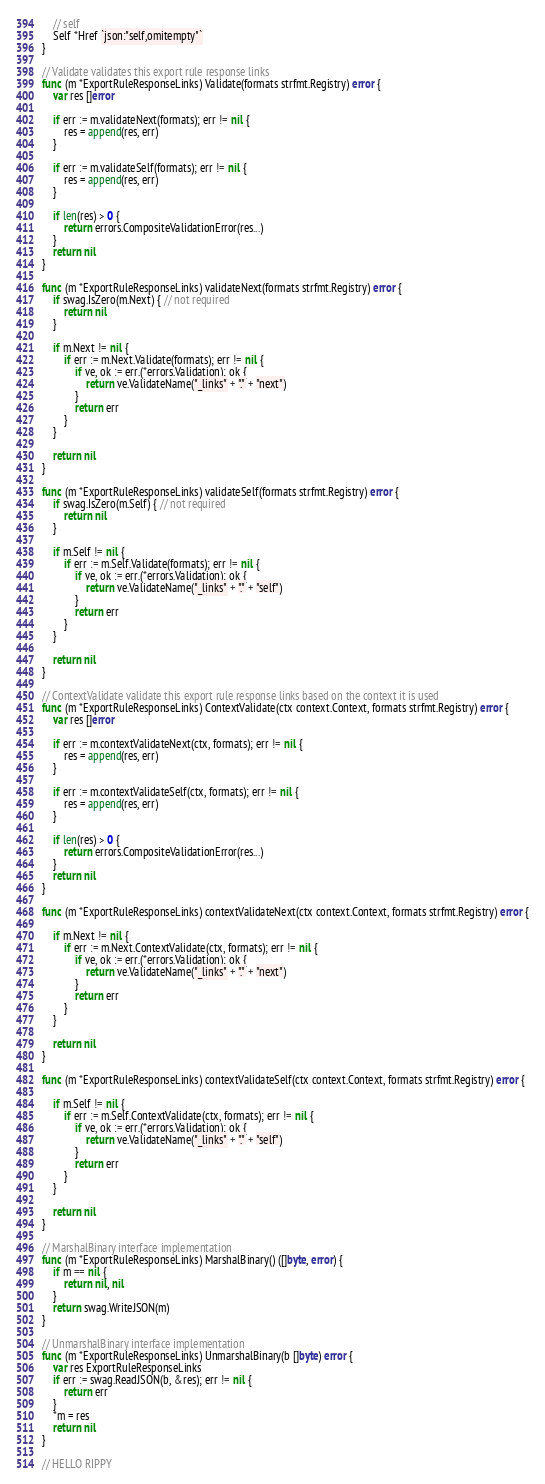<code> <loc_0><loc_0><loc_500><loc_500><_Go_>	// self
	Self *Href `json:"self,omitempty"`
}

// Validate validates this export rule response links
func (m *ExportRuleResponseLinks) Validate(formats strfmt.Registry) error {
	var res []error

	if err := m.validateNext(formats); err != nil {
		res = append(res, err)
	}

	if err := m.validateSelf(formats); err != nil {
		res = append(res, err)
	}

	if len(res) > 0 {
		return errors.CompositeValidationError(res...)
	}
	return nil
}

func (m *ExportRuleResponseLinks) validateNext(formats strfmt.Registry) error {
	if swag.IsZero(m.Next) { // not required
		return nil
	}

	if m.Next != nil {
		if err := m.Next.Validate(formats); err != nil {
			if ve, ok := err.(*errors.Validation); ok {
				return ve.ValidateName("_links" + "." + "next")
			}
			return err
		}
	}

	return nil
}

func (m *ExportRuleResponseLinks) validateSelf(formats strfmt.Registry) error {
	if swag.IsZero(m.Self) { // not required
		return nil
	}

	if m.Self != nil {
		if err := m.Self.Validate(formats); err != nil {
			if ve, ok := err.(*errors.Validation); ok {
				return ve.ValidateName("_links" + "." + "self")
			}
			return err
		}
	}

	return nil
}

// ContextValidate validate this export rule response links based on the context it is used
func (m *ExportRuleResponseLinks) ContextValidate(ctx context.Context, formats strfmt.Registry) error {
	var res []error

	if err := m.contextValidateNext(ctx, formats); err != nil {
		res = append(res, err)
	}

	if err := m.contextValidateSelf(ctx, formats); err != nil {
		res = append(res, err)
	}

	if len(res) > 0 {
		return errors.CompositeValidationError(res...)
	}
	return nil
}

func (m *ExportRuleResponseLinks) contextValidateNext(ctx context.Context, formats strfmt.Registry) error {

	if m.Next != nil {
		if err := m.Next.ContextValidate(ctx, formats); err != nil {
			if ve, ok := err.(*errors.Validation); ok {
				return ve.ValidateName("_links" + "." + "next")
			}
			return err
		}
	}

	return nil
}

func (m *ExportRuleResponseLinks) contextValidateSelf(ctx context.Context, formats strfmt.Registry) error {

	if m.Self != nil {
		if err := m.Self.ContextValidate(ctx, formats); err != nil {
			if ve, ok := err.(*errors.Validation); ok {
				return ve.ValidateName("_links" + "." + "self")
			}
			return err
		}
	}

	return nil
}

// MarshalBinary interface implementation
func (m *ExportRuleResponseLinks) MarshalBinary() ([]byte, error) {
	if m == nil {
		return nil, nil
	}
	return swag.WriteJSON(m)
}

// UnmarshalBinary interface implementation
func (m *ExportRuleResponseLinks) UnmarshalBinary(b []byte) error {
	var res ExportRuleResponseLinks
	if err := swag.ReadJSON(b, &res); err != nil {
		return err
	}
	*m = res
	return nil
}

// HELLO RIPPY
</code> 